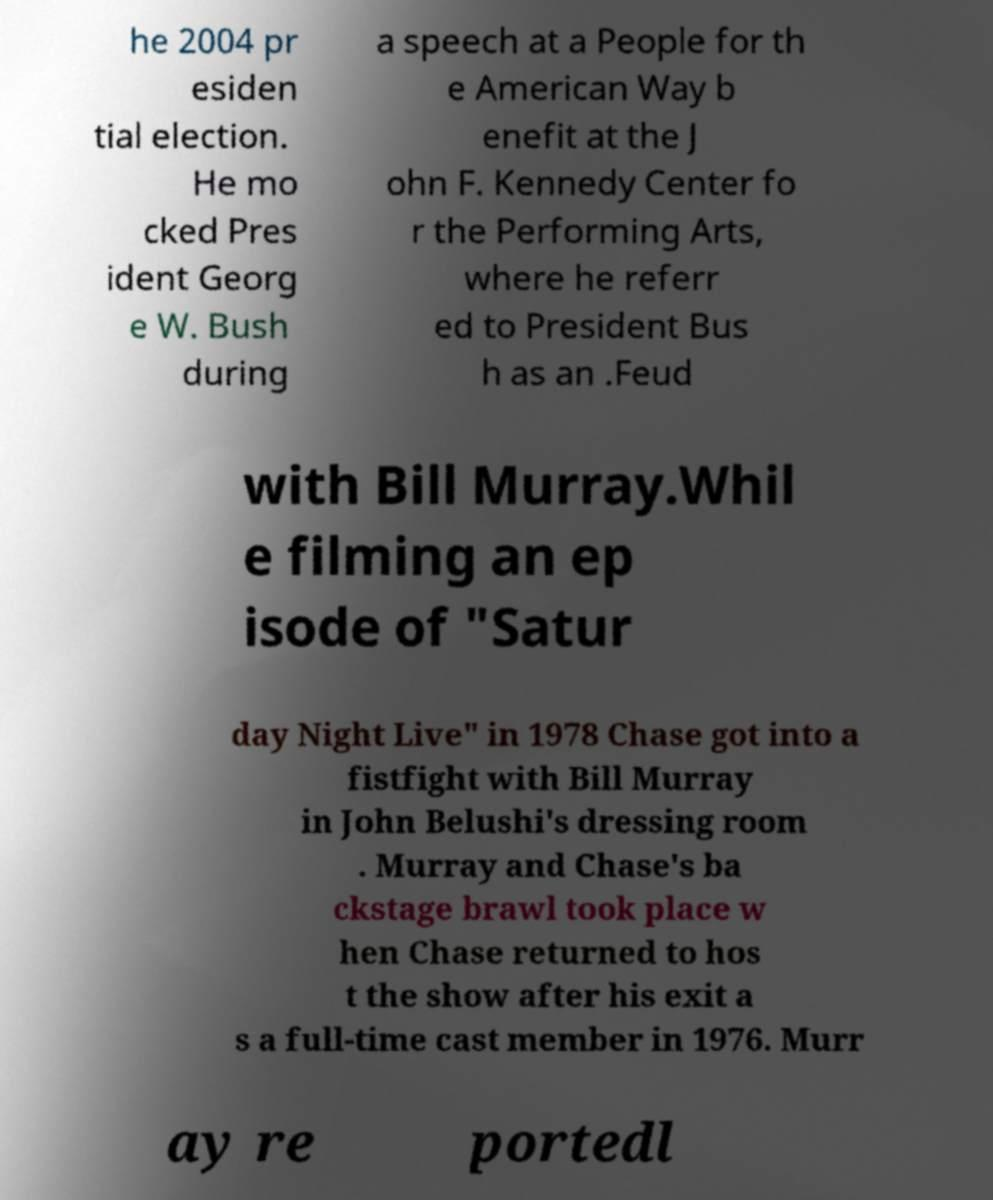What messages or text are displayed in this image? I need them in a readable, typed format. he 2004 pr esiden tial election. He mo cked Pres ident Georg e W. Bush during a speech at a People for th e American Way b enefit at the J ohn F. Kennedy Center fo r the Performing Arts, where he referr ed to President Bus h as an .Feud with Bill Murray.Whil e filming an ep isode of "Satur day Night Live" in 1978 Chase got into a fistfight with Bill Murray in John Belushi's dressing room . Murray and Chase's ba ckstage brawl took place w hen Chase returned to hos t the show after his exit a s a full-time cast member in 1976. Murr ay re portedl 